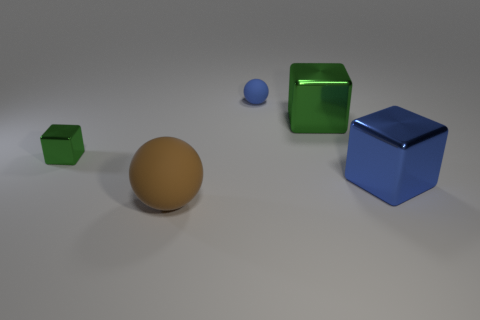There is a small matte ball; is its color the same as the object that is on the right side of the large green cube?
Keep it short and to the point. Yes. Are there an equal number of objects behind the blue metallic object and tiny shiny blocks?
Your response must be concise. No. What number of blue metallic things have the same size as the brown thing?
Ensure brevity in your answer.  1. What shape is the big thing that is the same color as the small shiny block?
Your answer should be compact. Cube. Are any tiny blue things visible?
Provide a succinct answer. Yes. Does the matte object that is on the left side of the blue rubber ball have the same shape as the green object on the left side of the big brown object?
Your answer should be very brief. No. How many large things are either gray shiny objects or blue balls?
Offer a very short reply. 0. There is a large thing that is the same material as the small blue thing; what is its shape?
Your response must be concise. Sphere. Is the shape of the small shiny thing the same as the brown object?
Offer a terse response. No. The tiny shiny object has what color?
Your answer should be compact. Green. 